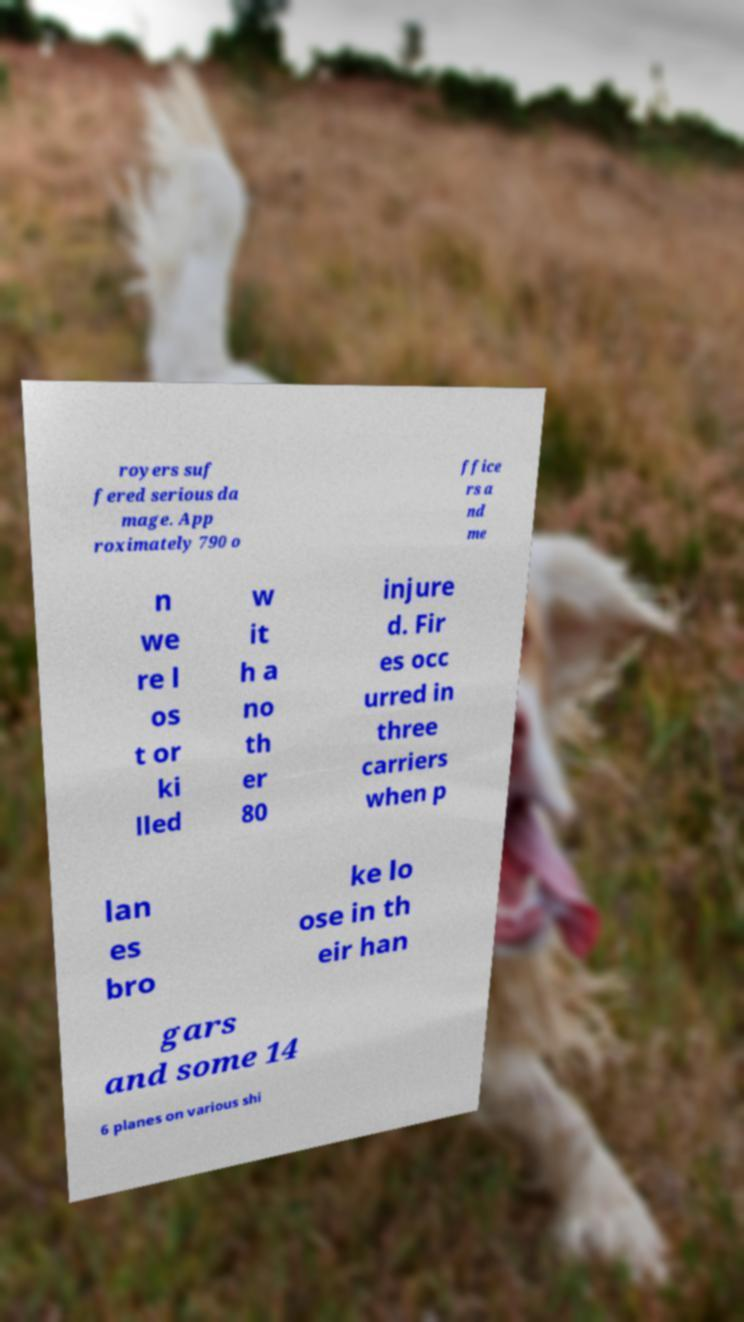What messages or text are displayed in this image? I need them in a readable, typed format. royers suf fered serious da mage. App roximately 790 o ffice rs a nd me n we re l os t or ki lled w it h a no th er 80 injure d. Fir es occ urred in three carriers when p lan es bro ke lo ose in th eir han gars and some 14 6 planes on various shi 